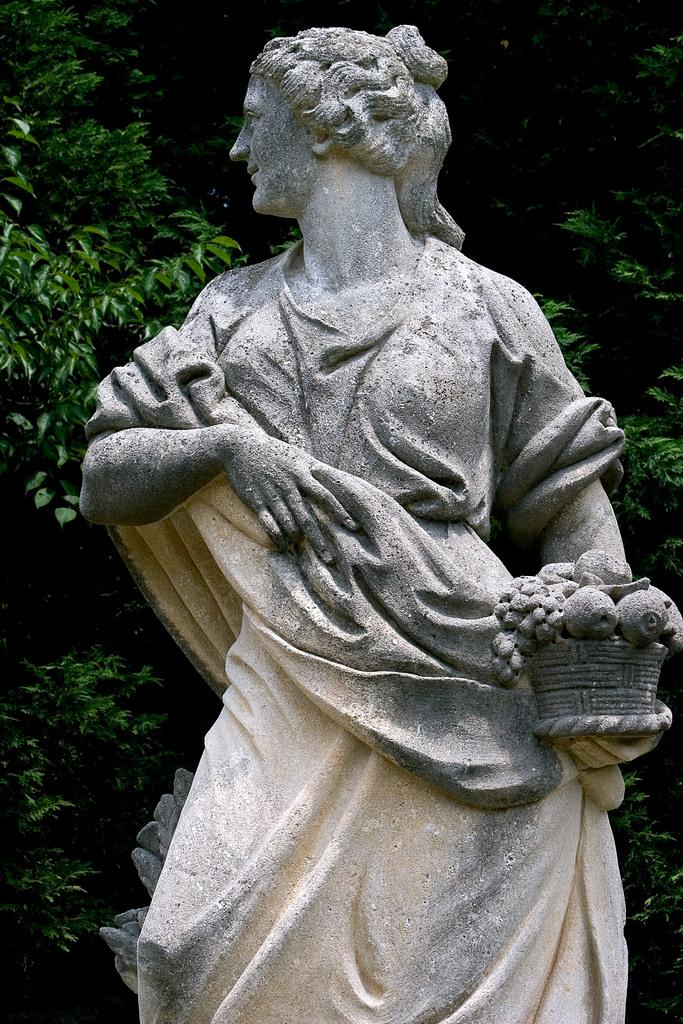What is the main subject of the image? There is a statue in the image. Can you describe the statue? The statue is of a girl. What is the girl holding in the statue? The girl is holding a basket. What is inside the basket? There are fruits in the basket. What can be seen in the background of the image? There are trees in the background of the image. What type of government is depicted in the statue? The statue does not depict any form of government; it is a statue of a girl holding a basket with fruits. How many snails can be seen crawling on the statue? There are no snails present in the image; it features a statue of a girl holding a basket with fruits. 